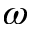Convert formula to latex. <formula><loc_0><loc_0><loc_500><loc_500>\omega</formula> 